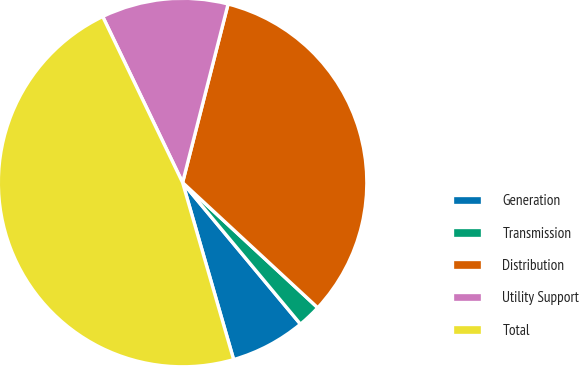Convert chart. <chart><loc_0><loc_0><loc_500><loc_500><pie_chart><fcel>Generation<fcel>Transmission<fcel>Distribution<fcel>Utility Support<fcel>Total<nl><fcel>6.58%<fcel>2.06%<fcel>32.92%<fcel>11.11%<fcel>47.33%<nl></chart> 